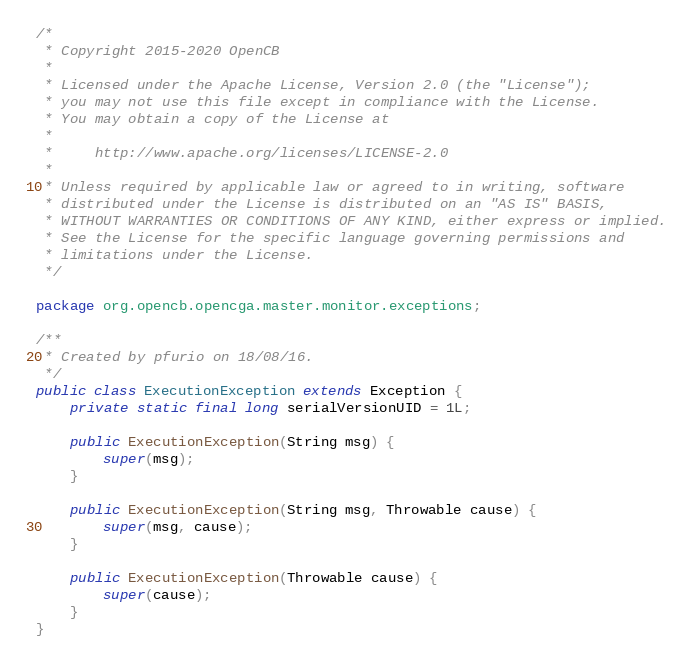<code> <loc_0><loc_0><loc_500><loc_500><_Java_>/*
 * Copyright 2015-2020 OpenCB
 *
 * Licensed under the Apache License, Version 2.0 (the "License");
 * you may not use this file except in compliance with the License.
 * You may obtain a copy of the License at
 *
 *     http://www.apache.org/licenses/LICENSE-2.0
 *
 * Unless required by applicable law or agreed to in writing, software
 * distributed under the License is distributed on an "AS IS" BASIS,
 * WITHOUT WARRANTIES OR CONDITIONS OF ANY KIND, either express or implied.
 * See the License for the specific language governing permissions and
 * limitations under the License.
 */

package org.opencb.opencga.master.monitor.exceptions;

/**
 * Created by pfurio on 18/08/16.
 */
public class ExecutionException extends Exception {
    private static final long serialVersionUID = 1L;

    public ExecutionException(String msg) {
        super(msg);
    }

    public ExecutionException(String msg, Throwable cause) {
        super(msg, cause);
    }

    public ExecutionException(Throwable cause) {
        super(cause);
    }
}
</code> 